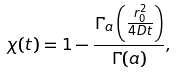<formula> <loc_0><loc_0><loc_500><loc_500>\chi ( t ) = 1 - \frac { \Gamma _ { a } \left ( \frac { r _ { 0 } ^ { 2 } } { 4 D t } \right ) } { \Gamma ( a ) } ,</formula> 